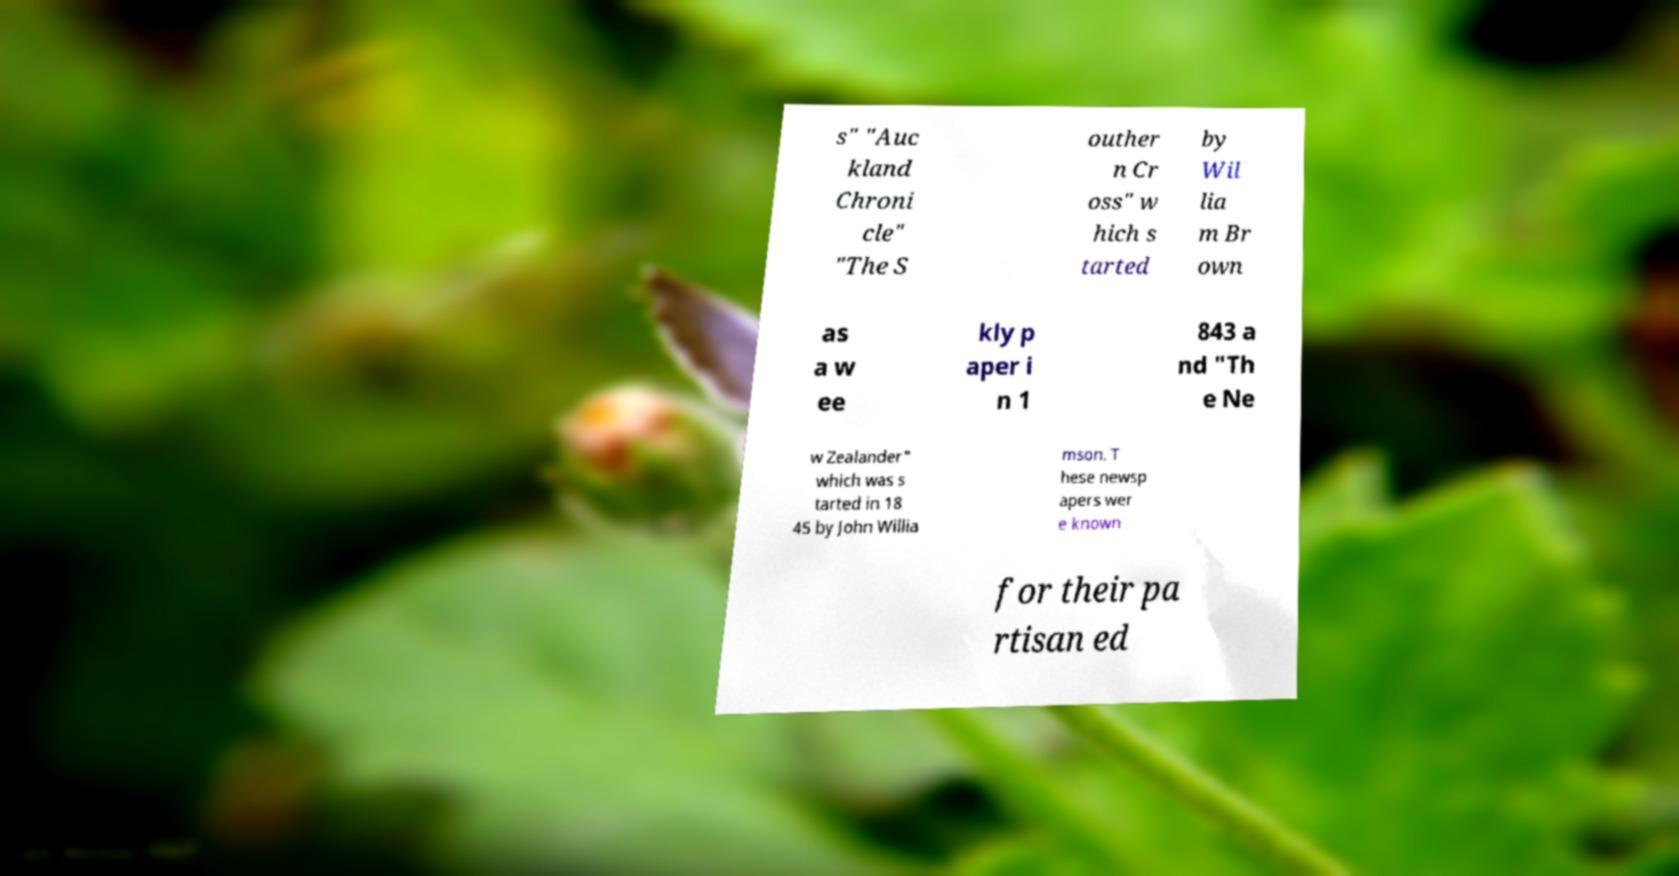There's text embedded in this image that I need extracted. Can you transcribe it verbatim? s" "Auc kland Chroni cle" "The S outher n Cr oss" w hich s tarted by Wil lia m Br own as a w ee kly p aper i n 1 843 a nd "Th e Ne w Zealander" which was s tarted in 18 45 by John Willia mson. T hese newsp apers wer e known for their pa rtisan ed 